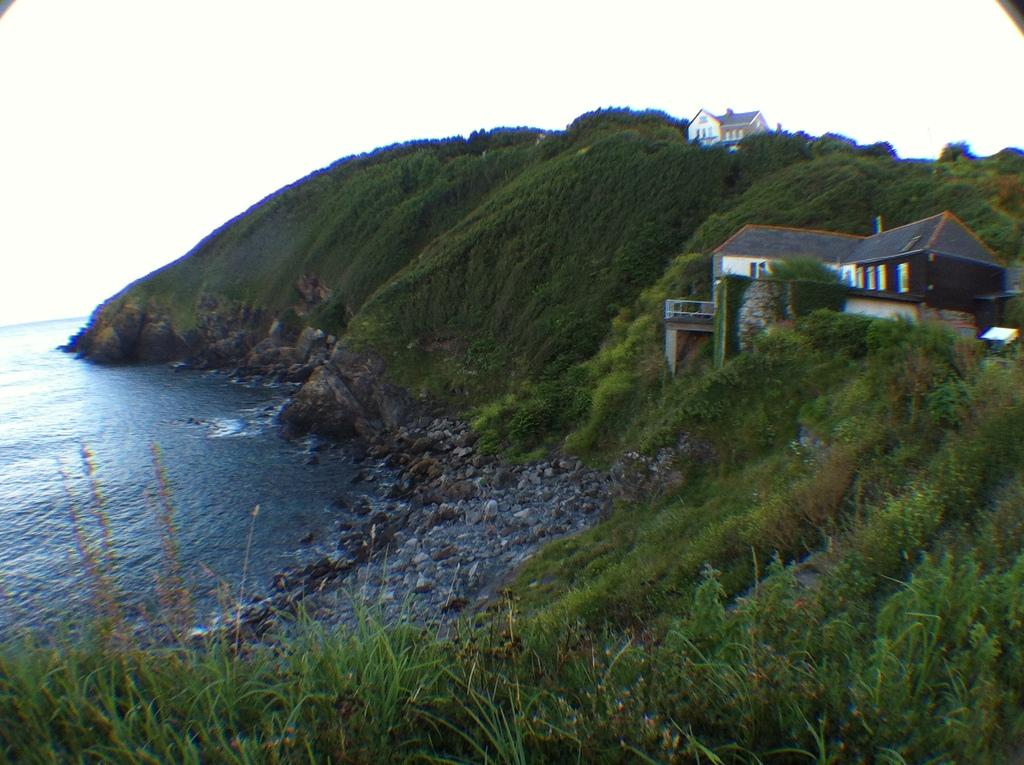What type of structures can be seen in the image? There are houses in the image. What natural features are present in the image? There are hills in the image. What can be seen at the bottom of the image? There is water visible at the bottom of the image. What type of zinc is present in the image? There is no zinc present in the image. How many accounts can be seen in the image? There are no accounts visible in the image. 